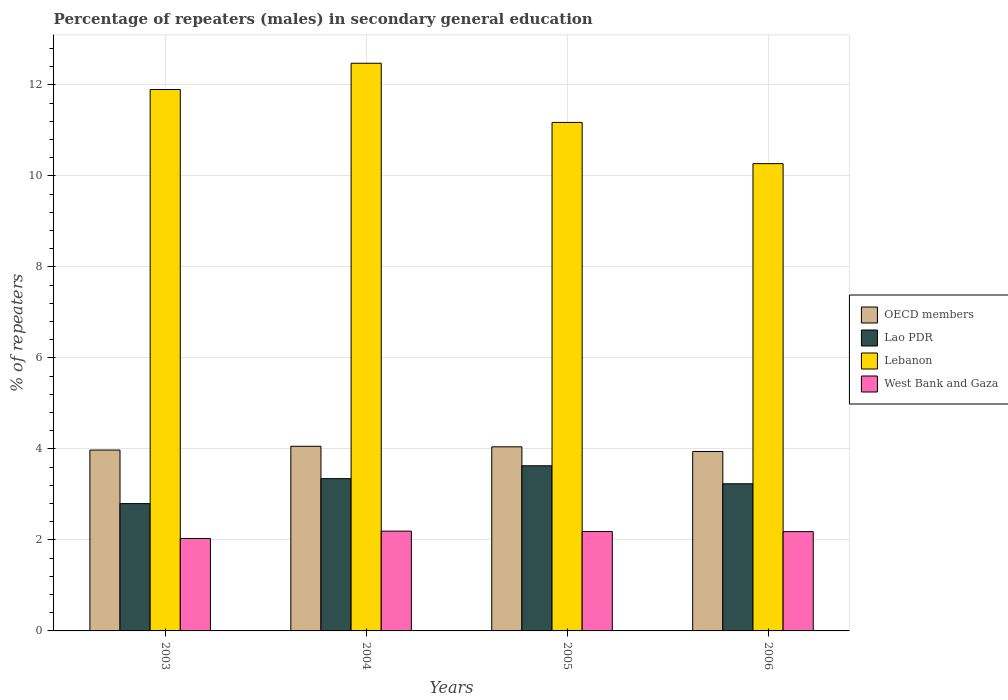Are the number of bars per tick equal to the number of legend labels?
Your answer should be very brief. Yes. How many bars are there on the 1st tick from the right?
Provide a short and direct response. 4. In how many cases, is the number of bars for a given year not equal to the number of legend labels?
Make the answer very short. 0. What is the percentage of male repeaters in OECD members in 2004?
Provide a short and direct response. 4.06. Across all years, what is the maximum percentage of male repeaters in Lebanon?
Offer a very short reply. 12.48. Across all years, what is the minimum percentage of male repeaters in OECD members?
Offer a terse response. 3.94. In which year was the percentage of male repeaters in Lebanon minimum?
Keep it short and to the point. 2006. What is the total percentage of male repeaters in OECD members in the graph?
Provide a short and direct response. 16.02. What is the difference between the percentage of male repeaters in Lao PDR in 2003 and that in 2006?
Offer a terse response. -0.44. What is the difference between the percentage of male repeaters in West Bank and Gaza in 2003 and the percentage of male repeaters in OECD members in 2006?
Ensure brevity in your answer.  -1.91. What is the average percentage of male repeaters in OECD members per year?
Your answer should be compact. 4.01. In the year 2003, what is the difference between the percentage of male repeaters in Lebanon and percentage of male repeaters in West Bank and Gaza?
Provide a short and direct response. 9.87. In how many years, is the percentage of male repeaters in OECD members greater than 3.6 %?
Offer a very short reply. 4. What is the ratio of the percentage of male repeaters in OECD members in 2005 to that in 2006?
Your answer should be compact. 1.03. Is the percentage of male repeaters in OECD members in 2005 less than that in 2006?
Offer a very short reply. No. Is the difference between the percentage of male repeaters in Lebanon in 2003 and 2005 greater than the difference between the percentage of male repeaters in West Bank and Gaza in 2003 and 2005?
Your answer should be very brief. Yes. What is the difference between the highest and the second highest percentage of male repeaters in West Bank and Gaza?
Your response must be concise. 0.01. What is the difference between the highest and the lowest percentage of male repeaters in Lao PDR?
Offer a terse response. 0.83. In how many years, is the percentage of male repeaters in Lao PDR greater than the average percentage of male repeaters in Lao PDR taken over all years?
Keep it short and to the point. 2. What does the 2nd bar from the left in 2003 represents?
Give a very brief answer. Lao PDR. What does the 4th bar from the right in 2006 represents?
Make the answer very short. OECD members. Is it the case that in every year, the sum of the percentage of male repeaters in West Bank and Gaza and percentage of male repeaters in Lao PDR is greater than the percentage of male repeaters in OECD members?
Your response must be concise. Yes. How many bars are there?
Provide a short and direct response. 16. Are all the bars in the graph horizontal?
Give a very brief answer. No. Are the values on the major ticks of Y-axis written in scientific E-notation?
Offer a terse response. No. Does the graph contain any zero values?
Offer a terse response. No. Where does the legend appear in the graph?
Your answer should be very brief. Center right. How many legend labels are there?
Your answer should be very brief. 4. What is the title of the graph?
Provide a short and direct response. Percentage of repeaters (males) in secondary general education. What is the label or title of the Y-axis?
Your answer should be compact. % of repeaters. What is the % of repeaters in OECD members in 2003?
Provide a succinct answer. 3.97. What is the % of repeaters in Lao PDR in 2003?
Ensure brevity in your answer.  2.8. What is the % of repeaters in Lebanon in 2003?
Make the answer very short. 11.9. What is the % of repeaters in West Bank and Gaza in 2003?
Provide a succinct answer. 2.03. What is the % of repeaters of OECD members in 2004?
Offer a terse response. 4.06. What is the % of repeaters of Lao PDR in 2004?
Offer a very short reply. 3.35. What is the % of repeaters in Lebanon in 2004?
Give a very brief answer. 12.48. What is the % of repeaters in West Bank and Gaza in 2004?
Ensure brevity in your answer.  2.19. What is the % of repeaters of OECD members in 2005?
Keep it short and to the point. 4.05. What is the % of repeaters of Lao PDR in 2005?
Give a very brief answer. 3.63. What is the % of repeaters in Lebanon in 2005?
Offer a terse response. 11.18. What is the % of repeaters of West Bank and Gaza in 2005?
Give a very brief answer. 2.18. What is the % of repeaters of OECD members in 2006?
Your answer should be very brief. 3.94. What is the % of repeaters of Lao PDR in 2006?
Keep it short and to the point. 3.23. What is the % of repeaters of Lebanon in 2006?
Your answer should be very brief. 10.27. What is the % of repeaters of West Bank and Gaza in 2006?
Offer a terse response. 2.18. Across all years, what is the maximum % of repeaters of OECD members?
Keep it short and to the point. 4.06. Across all years, what is the maximum % of repeaters in Lao PDR?
Provide a short and direct response. 3.63. Across all years, what is the maximum % of repeaters of Lebanon?
Provide a succinct answer. 12.48. Across all years, what is the maximum % of repeaters in West Bank and Gaza?
Keep it short and to the point. 2.19. Across all years, what is the minimum % of repeaters of OECD members?
Make the answer very short. 3.94. Across all years, what is the minimum % of repeaters of Lao PDR?
Your answer should be very brief. 2.8. Across all years, what is the minimum % of repeaters of Lebanon?
Give a very brief answer. 10.27. Across all years, what is the minimum % of repeaters in West Bank and Gaza?
Offer a very short reply. 2.03. What is the total % of repeaters in OECD members in the graph?
Your response must be concise. 16.02. What is the total % of repeaters in Lao PDR in the graph?
Your response must be concise. 13.01. What is the total % of repeaters of Lebanon in the graph?
Offer a terse response. 45.82. What is the total % of repeaters in West Bank and Gaza in the graph?
Make the answer very short. 8.59. What is the difference between the % of repeaters in OECD members in 2003 and that in 2004?
Your answer should be compact. -0.08. What is the difference between the % of repeaters of Lao PDR in 2003 and that in 2004?
Your response must be concise. -0.55. What is the difference between the % of repeaters of Lebanon in 2003 and that in 2004?
Provide a succinct answer. -0.58. What is the difference between the % of repeaters in West Bank and Gaza in 2003 and that in 2004?
Give a very brief answer. -0.16. What is the difference between the % of repeaters of OECD members in 2003 and that in 2005?
Your answer should be compact. -0.07. What is the difference between the % of repeaters in Lao PDR in 2003 and that in 2005?
Provide a succinct answer. -0.83. What is the difference between the % of repeaters of Lebanon in 2003 and that in 2005?
Make the answer very short. 0.72. What is the difference between the % of repeaters of West Bank and Gaza in 2003 and that in 2005?
Offer a very short reply. -0.15. What is the difference between the % of repeaters of OECD members in 2003 and that in 2006?
Your answer should be very brief. 0.03. What is the difference between the % of repeaters in Lao PDR in 2003 and that in 2006?
Provide a succinct answer. -0.44. What is the difference between the % of repeaters in Lebanon in 2003 and that in 2006?
Give a very brief answer. 1.63. What is the difference between the % of repeaters in West Bank and Gaza in 2003 and that in 2006?
Provide a short and direct response. -0.15. What is the difference between the % of repeaters in OECD members in 2004 and that in 2005?
Your answer should be very brief. 0.01. What is the difference between the % of repeaters of Lao PDR in 2004 and that in 2005?
Make the answer very short. -0.28. What is the difference between the % of repeaters of Lebanon in 2004 and that in 2005?
Give a very brief answer. 1.3. What is the difference between the % of repeaters in West Bank and Gaza in 2004 and that in 2005?
Your answer should be compact. 0.01. What is the difference between the % of repeaters in OECD members in 2004 and that in 2006?
Give a very brief answer. 0.11. What is the difference between the % of repeaters in Lao PDR in 2004 and that in 2006?
Give a very brief answer. 0.11. What is the difference between the % of repeaters in Lebanon in 2004 and that in 2006?
Your answer should be compact. 2.21. What is the difference between the % of repeaters of West Bank and Gaza in 2004 and that in 2006?
Make the answer very short. 0.01. What is the difference between the % of repeaters of OECD members in 2005 and that in 2006?
Provide a succinct answer. 0.1. What is the difference between the % of repeaters of Lao PDR in 2005 and that in 2006?
Your answer should be very brief. 0.4. What is the difference between the % of repeaters of Lebanon in 2005 and that in 2006?
Offer a very short reply. 0.91. What is the difference between the % of repeaters of West Bank and Gaza in 2005 and that in 2006?
Ensure brevity in your answer.  0. What is the difference between the % of repeaters of OECD members in 2003 and the % of repeaters of Lao PDR in 2004?
Give a very brief answer. 0.63. What is the difference between the % of repeaters of OECD members in 2003 and the % of repeaters of Lebanon in 2004?
Provide a succinct answer. -8.5. What is the difference between the % of repeaters in OECD members in 2003 and the % of repeaters in West Bank and Gaza in 2004?
Make the answer very short. 1.78. What is the difference between the % of repeaters in Lao PDR in 2003 and the % of repeaters in Lebanon in 2004?
Your response must be concise. -9.68. What is the difference between the % of repeaters in Lao PDR in 2003 and the % of repeaters in West Bank and Gaza in 2004?
Give a very brief answer. 0.61. What is the difference between the % of repeaters in Lebanon in 2003 and the % of repeaters in West Bank and Gaza in 2004?
Keep it short and to the point. 9.71. What is the difference between the % of repeaters in OECD members in 2003 and the % of repeaters in Lao PDR in 2005?
Give a very brief answer. 0.35. What is the difference between the % of repeaters of OECD members in 2003 and the % of repeaters of Lebanon in 2005?
Make the answer very short. -7.2. What is the difference between the % of repeaters of OECD members in 2003 and the % of repeaters of West Bank and Gaza in 2005?
Your answer should be compact. 1.79. What is the difference between the % of repeaters in Lao PDR in 2003 and the % of repeaters in Lebanon in 2005?
Your answer should be compact. -8.38. What is the difference between the % of repeaters in Lao PDR in 2003 and the % of repeaters in West Bank and Gaza in 2005?
Provide a short and direct response. 0.61. What is the difference between the % of repeaters in Lebanon in 2003 and the % of repeaters in West Bank and Gaza in 2005?
Your answer should be very brief. 9.71. What is the difference between the % of repeaters of OECD members in 2003 and the % of repeaters of Lao PDR in 2006?
Give a very brief answer. 0.74. What is the difference between the % of repeaters in OECD members in 2003 and the % of repeaters in Lebanon in 2006?
Offer a terse response. -6.29. What is the difference between the % of repeaters of OECD members in 2003 and the % of repeaters of West Bank and Gaza in 2006?
Your response must be concise. 1.79. What is the difference between the % of repeaters of Lao PDR in 2003 and the % of repeaters of Lebanon in 2006?
Your answer should be very brief. -7.47. What is the difference between the % of repeaters of Lao PDR in 2003 and the % of repeaters of West Bank and Gaza in 2006?
Provide a succinct answer. 0.62. What is the difference between the % of repeaters in Lebanon in 2003 and the % of repeaters in West Bank and Gaza in 2006?
Offer a very short reply. 9.72. What is the difference between the % of repeaters in OECD members in 2004 and the % of repeaters in Lao PDR in 2005?
Ensure brevity in your answer.  0.43. What is the difference between the % of repeaters of OECD members in 2004 and the % of repeaters of Lebanon in 2005?
Provide a short and direct response. -7.12. What is the difference between the % of repeaters in OECD members in 2004 and the % of repeaters in West Bank and Gaza in 2005?
Offer a terse response. 1.87. What is the difference between the % of repeaters of Lao PDR in 2004 and the % of repeaters of Lebanon in 2005?
Your answer should be compact. -7.83. What is the difference between the % of repeaters of Lao PDR in 2004 and the % of repeaters of West Bank and Gaza in 2005?
Offer a terse response. 1.16. What is the difference between the % of repeaters in Lebanon in 2004 and the % of repeaters in West Bank and Gaza in 2005?
Your response must be concise. 10.29. What is the difference between the % of repeaters of OECD members in 2004 and the % of repeaters of Lao PDR in 2006?
Give a very brief answer. 0.82. What is the difference between the % of repeaters in OECD members in 2004 and the % of repeaters in Lebanon in 2006?
Offer a very short reply. -6.21. What is the difference between the % of repeaters in OECD members in 2004 and the % of repeaters in West Bank and Gaza in 2006?
Provide a short and direct response. 1.88. What is the difference between the % of repeaters in Lao PDR in 2004 and the % of repeaters in Lebanon in 2006?
Provide a succinct answer. -6.92. What is the difference between the % of repeaters in Lao PDR in 2004 and the % of repeaters in West Bank and Gaza in 2006?
Your answer should be compact. 1.17. What is the difference between the % of repeaters of Lebanon in 2004 and the % of repeaters of West Bank and Gaza in 2006?
Keep it short and to the point. 10.29. What is the difference between the % of repeaters of OECD members in 2005 and the % of repeaters of Lao PDR in 2006?
Give a very brief answer. 0.81. What is the difference between the % of repeaters in OECD members in 2005 and the % of repeaters in Lebanon in 2006?
Provide a succinct answer. -6.22. What is the difference between the % of repeaters of OECD members in 2005 and the % of repeaters of West Bank and Gaza in 2006?
Your answer should be compact. 1.86. What is the difference between the % of repeaters of Lao PDR in 2005 and the % of repeaters of Lebanon in 2006?
Give a very brief answer. -6.64. What is the difference between the % of repeaters in Lao PDR in 2005 and the % of repeaters in West Bank and Gaza in 2006?
Your answer should be compact. 1.45. What is the difference between the % of repeaters in Lebanon in 2005 and the % of repeaters in West Bank and Gaza in 2006?
Keep it short and to the point. 8.99. What is the average % of repeaters of OECD members per year?
Your answer should be compact. 4.01. What is the average % of repeaters in Lao PDR per year?
Your response must be concise. 3.25. What is the average % of repeaters in Lebanon per year?
Keep it short and to the point. 11.45. What is the average % of repeaters in West Bank and Gaza per year?
Make the answer very short. 2.15. In the year 2003, what is the difference between the % of repeaters of OECD members and % of repeaters of Lao PDR?
Provide a succinct answer. 1.18. In the year 2003, what is the difference between the % of repeaters in OECD members and % of repeaters in Lebanon?
Make the answer very short. -7.92. In the year 2003, what is the difference between the % of repeaters of OECD members and % of repeaters of West Bank and Gaza?
Provide a short and direct response. 1.94. In the year 2003, what is the difference between the % of repeaters in Lao PDR and % of repeaters in Lebanon?
Your answer should be compact. -9.1. In the year 2003, what is the difference between the % of repeaters in Lao PDR and % of repeaters in West Bank and Gaza?
Your answer should be compact. 0.77. In the year 2003, what is the difference between the % of repeaters of Lebanon and % of repeaters of West Bank and Gaza?
Your answer should be compact. 9.87. In the year 2004, what is the difference between the % of repeaters of OECD members and % of repeaters of Lao PDR?
Provide a succinct answer. 0.71. In the year 2004, what is the difference between the % of repeaters in OECD members and % of repeaters in Lebanon?
Your answer should be very brief. -8.42. In the year 2004, what is the difference between the % of repeaters of OECD members and % of repeaters of West Bank and Gaza?
Your answer should be compact. 1.86. In the year 2004, what is the difference between the % of repeaters of Lao PDR and % of repeaters of Lebanon?
Ensure brevity in your answer.  -9.13. In the year 2004, what is the difference between the % of repeaters of Lao PDR and % of repeaters of West Bank and Gaza?
Your response must be concise. 1.15. In the year 2004, what is the difference between the % of repeaters of Lebanon and % of repeaters of West Bank and Gaza?
Provide a short and direct response. 10.28. In the year 2005, what is the difference between the % of repeaters of OECD members and % of repeaters of Lao PDR?
Offer a very short reply. 0.42. In the year 2005, what is the difference between the % of repeaters in OECD members and % of repeaters in Lebanon?
Your response must be concise. -7.13. In the year 2005, what is the difference between the % of repeaters of OECD members and % of repeaters of West Bank and Gaza?
Offer a terse response. 1.86. In the year 2005, what is the difference between the % of repeaters of Lao PDR and % of repeaters of Lebanon?
Make the answer very short. -7.55. In the year 2005, what is the difference between the % of repeaters of Lao PDR and % of repeaters of West Bank and Gaza?
Provide a short and direct response. 1.45. In the year 2005, what is the difference between the % of repeaters in Lebanon and % of repeaters in West Bank and Gaza?
Offer a very short reply. 8.99. In the year 2006, what is the difference between the % of repeaters of OECD members and % of repeaters of Lao PDR?
Your answer should be very brief. 0.71. In the year 2006, what is the difference between the % of repeaters of OECD members and % of repeaters of Lebanon?
Offer a very short reply. -6.33. In the year 2006, what is the difference between the % of repeaters of OECD members and % of repeaters of West Bank and Gaza?
Give a very brief answer. 1.76. In the year 2006, what is the difference between the % of repeaters of Lao PDR and % of repeaters of Lebanon?
Your answer should be compact. -7.04. In the year 2006, what is the difference between the % of repeaters in Lao PDR and % of repeaters in West Bank and Gaza?
Make the answer very short. 1.05. In the year 2006, what is the difference between the % of repeaters in Lebanon and % of repeaters in West Bank and Gaza?
Keep it short and to the point. 8.09. What is the ratio of the % of repeaters in OECD members in 2003 to that in 2004?
Ensure brevity in your answer.  0.98. What is the ratio of the % of repeaters in Lao PDR in 2003 to that in 2004?
Keep it short and to the point. 0.84. What is the ratio of the % of repeaters in Lebanon in 2003 to that in 2004?
Provide a short and direct response. 0.95. What is the ratio of the % of repeaters in West Bank and Gaza in 2003 to that in 2004?
Your response must be concise. 0.93. What is the ratio of the % of repeaters of OECD members in 2003 to that in 2005?
Give a very brief answer. 0.98. What is the ratio of the % of repeaters in Lao PDR in 2003 to that in 2005?
Your response must be concise. 0.77. What is the ratio of the % of repeaters in Lebanon in 2003 to that in 2005?
Make the answer very short. 1.06. What is the ratio of the % of repeaters in West Bank and Gaza in 2003 to that in 2005?
Your answer should be very brief. 0.93. What is the ratio of the % of repeaters in Lao PDR in 2003 to that in 2006?
Ensure brevity in your answer.  0.87. What is the ratio of the % of repeaters of Lebanon in 2003 to that in 2006?
Make the answer very short. 1.16. What is the ratio of the % of repeaters in West Bank and Gaza in 2003 to that in 2006?
Provide a succinct answer. 0.93. What is the ratio of the % of repeaters in Lao PDR in 2004 to that in 2005?
Offer a very short reply. 0.92. What is the ratio of the % of repeaters in Lebanon in 2004 to that in 2005?
Offer a very short reply. 1.12. What is the ratio of the % of repeaters in West Bank and Gaza in 2004 to that in 2005?
Provide a succinct answer. 1. What is the ratio of the % of repeaters of OECD members in 2004 to that in 2006?
Give a very brief answer. 1.03. What is the ratio of the % of repeaters in Lao PDR in 2004 to that in 2006?
Ensure brevity in your answer.  1.03. What is the ratio of the % of repeaters of Lebanon in 2004 to that in 2006?
Ensure brevity in your answer.  1.21. What is the ratio of the % of repeaters in OECD members in 2005 to that in 2006?
Keep it short and to the point. 1.03. What is the ratio of the % of repeaters of Lao PDR in 2005 to that in 2006?
Keep it short and to the point. 1.12. What is the ratio of the % of repeaters in Lebanon in 2005 to that in 2006?
Keep it short and to the point. 1.09. What is the difference between the highest and the second highest % of repeaters in OECD members?
Offer a terse response. 0.01. What is the difference between the highest and the second highest % of repeaters of Lao PDR?
Provide a short and direct response. 0.28. What is the difference between the highest and the second highest % of repeaters in Lebanon?
Offer a terse response. 0.58. What is the difference between the highest and the second highest % of repeaters in West Bank and Gaza?
Provide a short and direct response. 0.01. What is the difference between the highest and the lowest % of repeaters in OECD members?
Offer a terse response. 0.11. What is the difference between the highest and the lowest % of repeaters of Lao PDR?
Your answer should be very brief. 0.83. What is the difference between the highest and the lowest % of repeaters of Lebanon?
Offer a very short reply. 2.21. What is the difference between the highest and the lowest % of repeaters in West Bank and Gaza?
Make the answer very short. 0.16. 